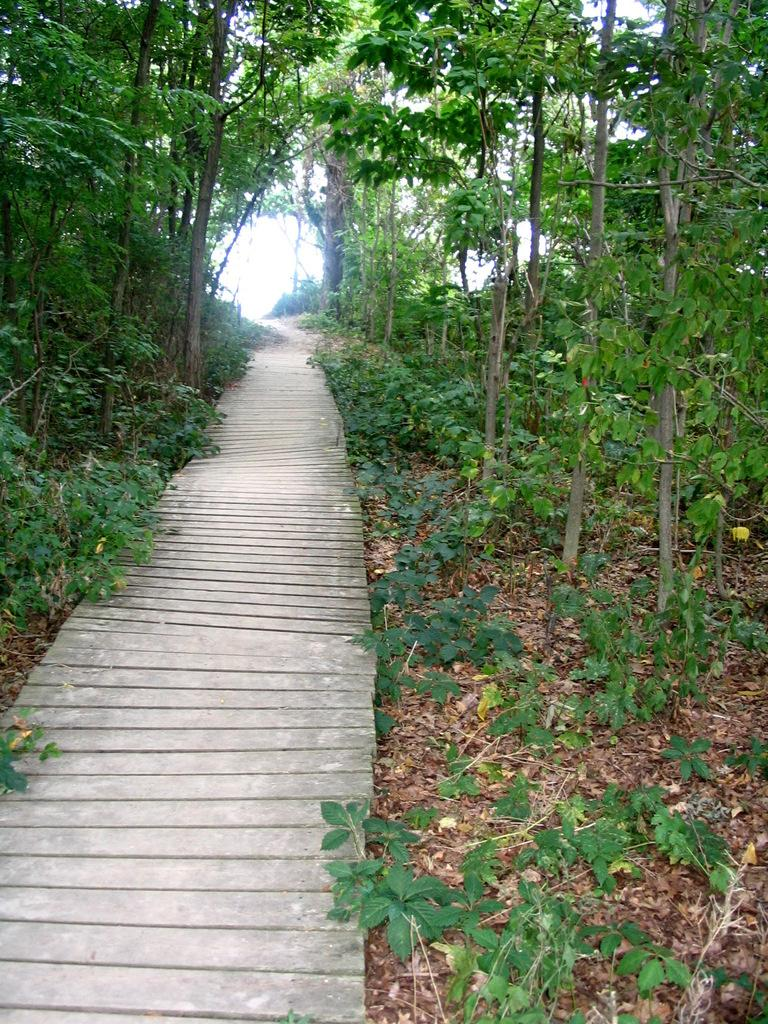What can be seen in the image that people might walk on? There is a path in the image that people might walk on. What is covering the ground in the image? Dried leaves are present on the ground in the image. What can be seen in the distance in the image? There are trees visible in the background of the image. Can you hear the goldfish swimming in the image? There are no goldfish present in the image, so it is not possible to hear them swimming. 